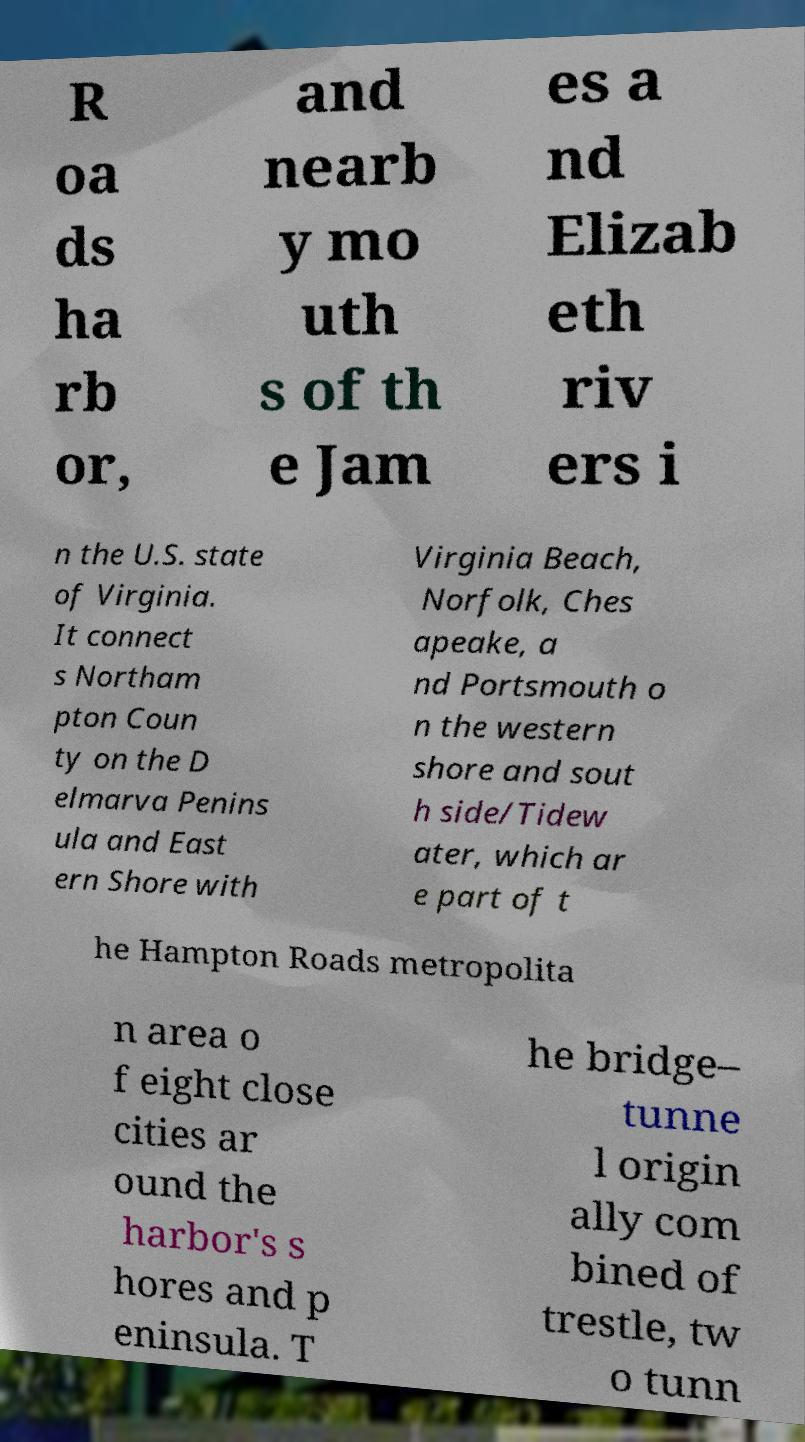There's text embedded in this image that I need extracted. Can you transcribe it verbatim? R oa ds ha rb or, and nearb y mo uth s of th e Jam es a nd Elizab eth riv ers i n the U.S. state of Virginia. It connect s Northam pton Coun ty on the D elmarva Penins ula and East ern Shore with Virginia Beach, Norfolk, Ches apeake, a nd Portsmouth o n the western shore and sout h side/Tidew ater, which ar e part of t he Hampton Roads metropolita n area o f eight close cities ar ound the harbor's s hores and p eninsula. T he bridge– tunne l origin ally com bined of trestle, tw o tunn 